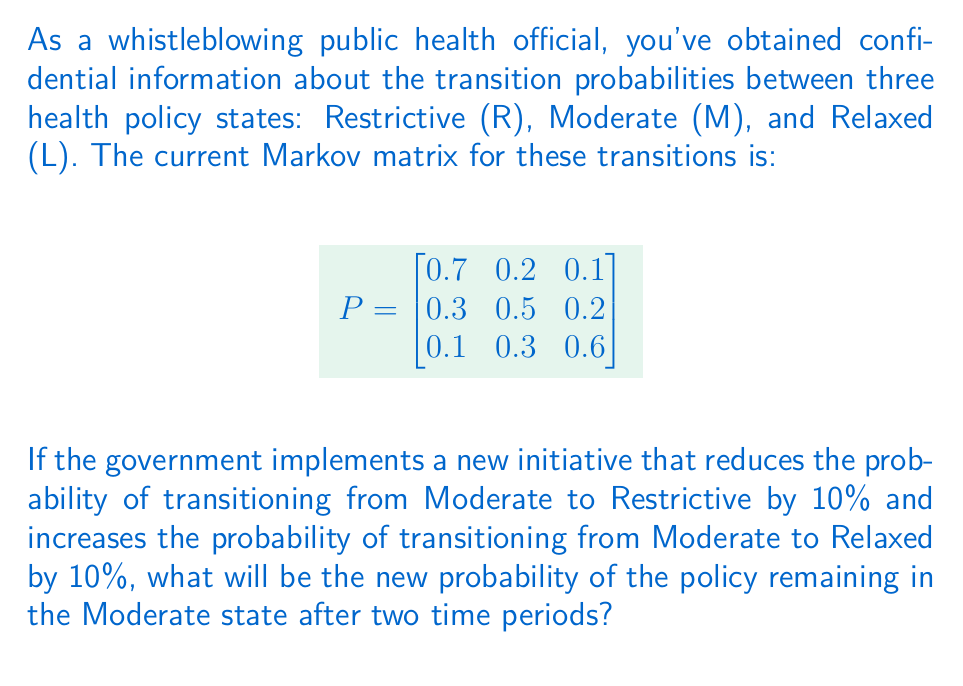Teach me how to tackle this problem. Let's approach this step-by-step:

1) First, we need to update the Markov matrix with the new transition probabilities for the Moderate state:

   - Probability of M to R decreases by 10%: 0.3 - 0.1 = 0.2
   - Probability of M to L increases by 10%: 0.2 + 0.1 = 0.3
   - Probability of M to M must adjust to make the row sum to 1: 1 - 0.2 - 0.3 = 0.5

2) The new Markov matrix $P_{new}$ is:

   $$
   P_{new} = \begin{bmatrix}
   0.7 & 0.2 & 0.1 \\
   0.2 & 0.5 & 0.3 \\
   0.1 & 0.3 & 0.6
   \end{bmatrix}
   $$

3) To find the probability after two time periods, we need to square this matrix:

   $$
   P_{new}^2 = P_{new} \times P_{new}
   $$

4) Multiplying the matrices:

   $$
   P_{new}^2 = \begin{bmatrix}
   0.53 & 0.29 & 0.18 \\
   0.27 & 0.41 & 0.32 \\
   0.19 & 0.33 & 0.48
   \end{bmatrix}
   $$

5) The probability of remaining in the Moderate state after two time periods is the element in the second row and second column of $P_{new}^2$, which is 0.41 or 41%.
Answer: 0.41 